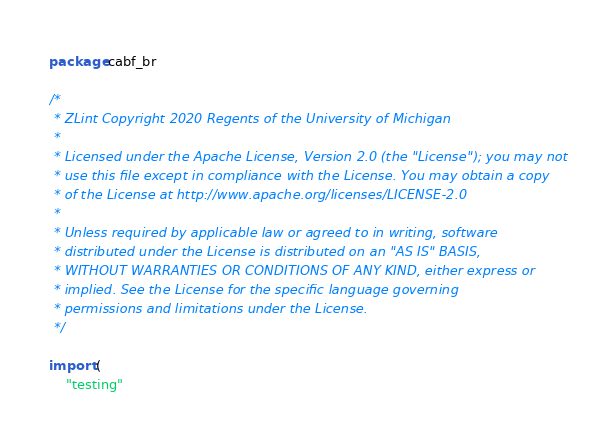<code> <loc_0><loc_0><loc_500><loc_500><_Go_>package cabf_br

/*
 * ZLint Copyright 2020 Regents of the University of Michigan
 *
 * Licensed under the Apache License, Version 2.0 (the "License"); you may not
 * use this file except in compliance with the License. You may obtain a copy
 * of the License at http://www.apache.org/licenses/LICENSE-2.0
 *
 * Unless required by applicable law or agreed to in writing, software
 * distributed under the License is distributed on an "AS IS" BASIS,
 * WITHOUT WARRANTIES OR CONDITIONS OF ANY KIND, either express or
 * implied. See the License for the specific language governing
 * permissions and limitations under the License.
 */

import (
	"testing"
</code> 